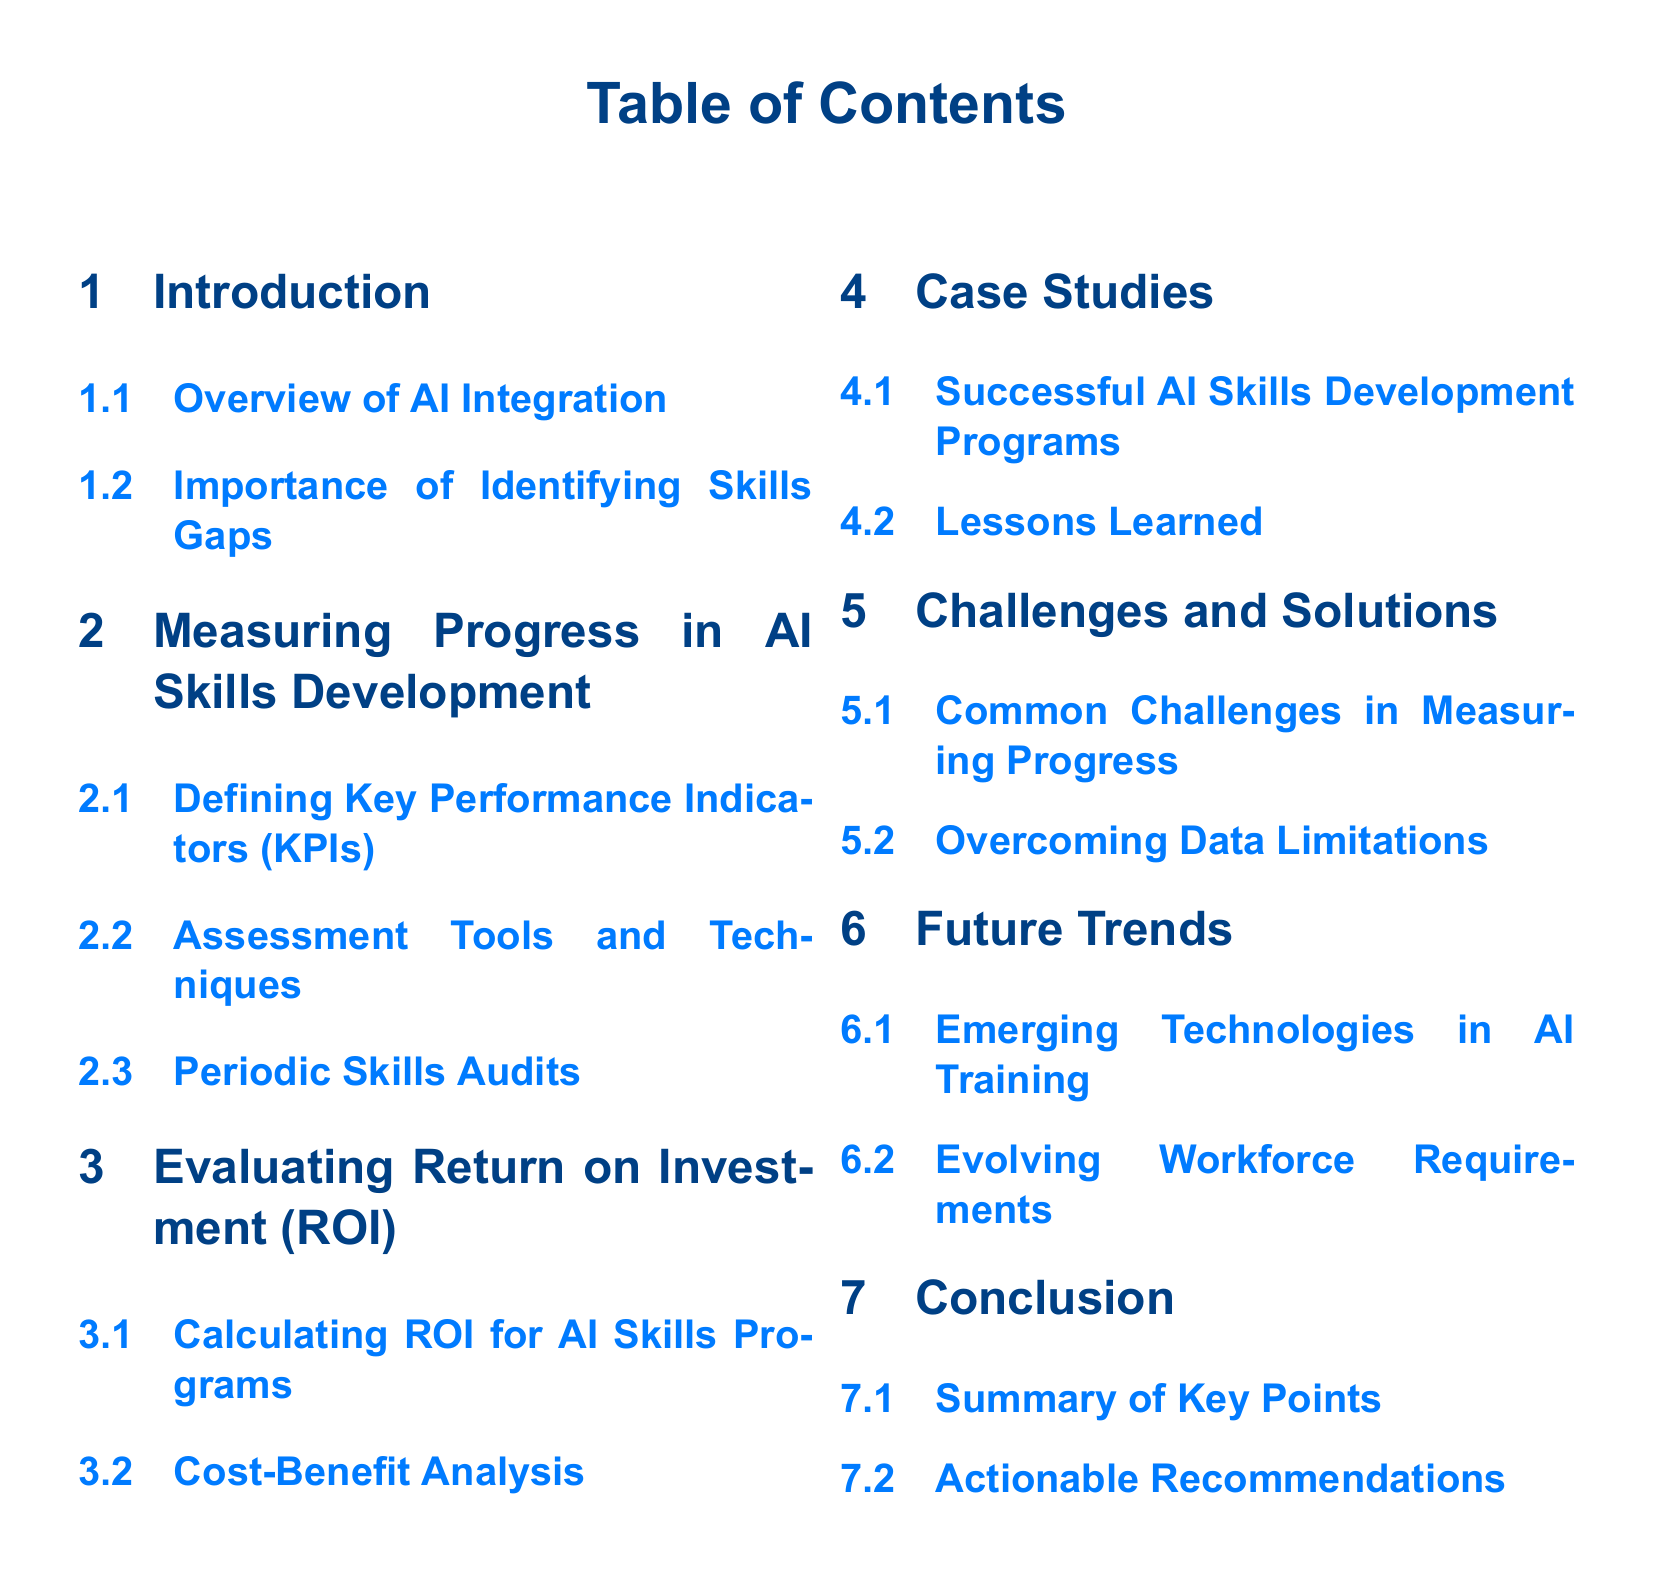What is the main focus of the document? The main focus of the document is to outline strategies for measuring progress and ROI of AI skills development programs.
Answer: AI skills development programs What section discusses key performance indicators? The section that discusses key performance indicators is specifically about measuring progress in AI skills development.
Answer: Measuring Progress in AI Skills Development How many subsections are in the Challenges and Solutions section? The Challenges and Solutions section contains two subsections.
Answer: 2 What is one method mentioned for evaluating ROI? The methods mentioned for evaluating ROI include calculating ROI for AI skills programs.
Answer: Calculating ROI for AI Skills Programs What type of case studies are included in the document? The case studies include successful AI skills development programs and lessons learned from them.
Answer: Successful AI Skills Development Programs What is the document's last section focused on? The last section focuses on summarizing key points and providing actionable recommendations.
Answer: Conclusion Which emerging area is addressed in the Future Trends section? The Future Trends section addresses emerging technologies in AI training.
Answer: Emerging Technologies in AI Training What is emphasized in the Importance of Identifying Skills Gaps subsection? This subsection emphasizes the necessity of identifying skills gaps for successful AI integration.
Answer: Identifying skills gaps 